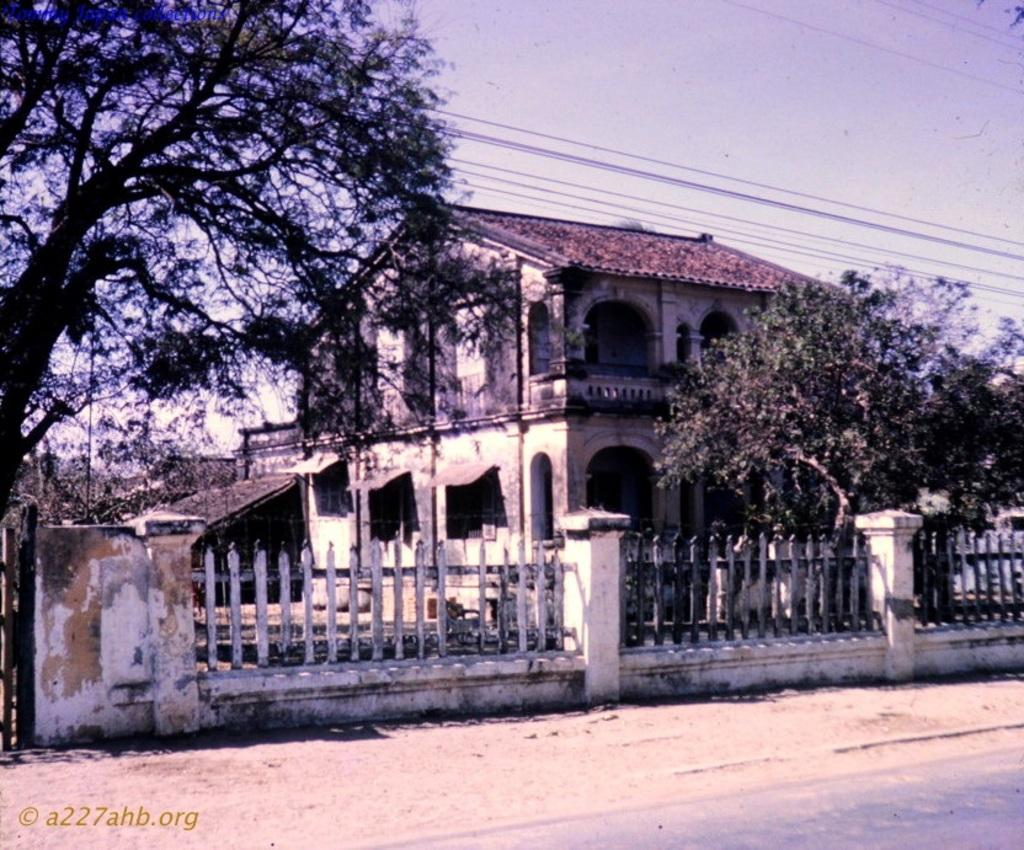What type of structure is visible in the image? There is a house in the image. What features can be seen on the house? The house has windows and a roof. What other objects or elements are present in the image? There is a group of trees, a fence, pillars, a road, wires, and the sky is visible. How does the sky appear in the image? The sky appears to be cloudy. What color of paint is used on the card held by the pet in the image? There is no card or pet present in the image. What type of pet can be seen interacting with the house in the image? There is no pet present in the image. 